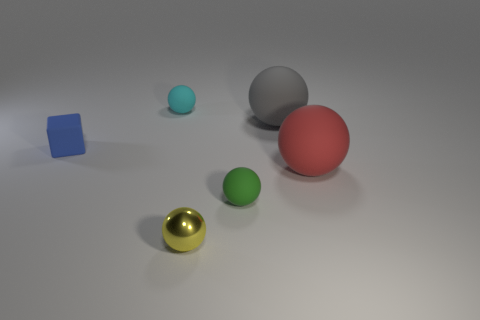Subtract all gray balls. How many balls are left? 4 Subtract 1 spheres. How many spheres are left? 4 Subtract all tiny yellow metallic spheres. How many spheres are left? 4 Subtract all red balls. Subtract all blue cylinders. How many balls are left? 4 Add 1 big green metallic objects. How many objects exist? 7 Subtract all cubes. How many objects are left? 5 Subtract all big green rubber cubes. Subtract all red rubber objects. How many objects are left? 5 Add 4 cyan spheres. How many cyan spheres are left? 5 Add 2 gray things. How many gray things exist? 3 Subtract 0 brown cylinders. How many objects are left? 6 